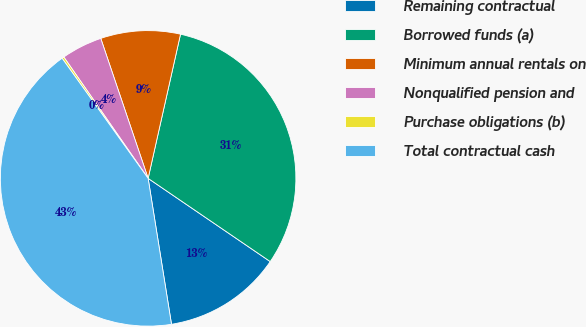Convert chart to OTSL. <chart><loc_0><loc_0><loc_500><loc_500><pie_chart><fcel>Remaining contractual<fcel>Borrowed funds (a)<fcel>Minimum annual rentals on<fcel>Nonqualified pension and<fcel>Purchase obligations (b)<fcel>Total contractual cash<nl><fcel>12.95%<fcel>31.0%<fcel>8.71%<fcel>4.47%<fcel>0.23%<fcel>42.63%<nl></chart> 